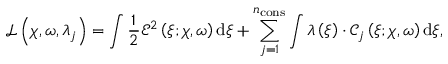<formula> <loc_0><loc_0><loc_500><loc_500>\mathcal { L } \left ( \boldsymbol \chi , \omega , \lambda _ { j } \right ) = \int \frac { 1 } { 2 } \mathcal { E } ^ { 2 } \left ( \xi ; \boldsymbol \chi , \omega \right ) d \xi + \sum _ { j = 1 } ^ { n _ { c o n s } } \int \lambda \left ( \xi \right ) \cdot \mathcal { C } _ { j } \left ( \xi ; \boldsymbol \chi , \omega \right ) d \xi ,</formula> 